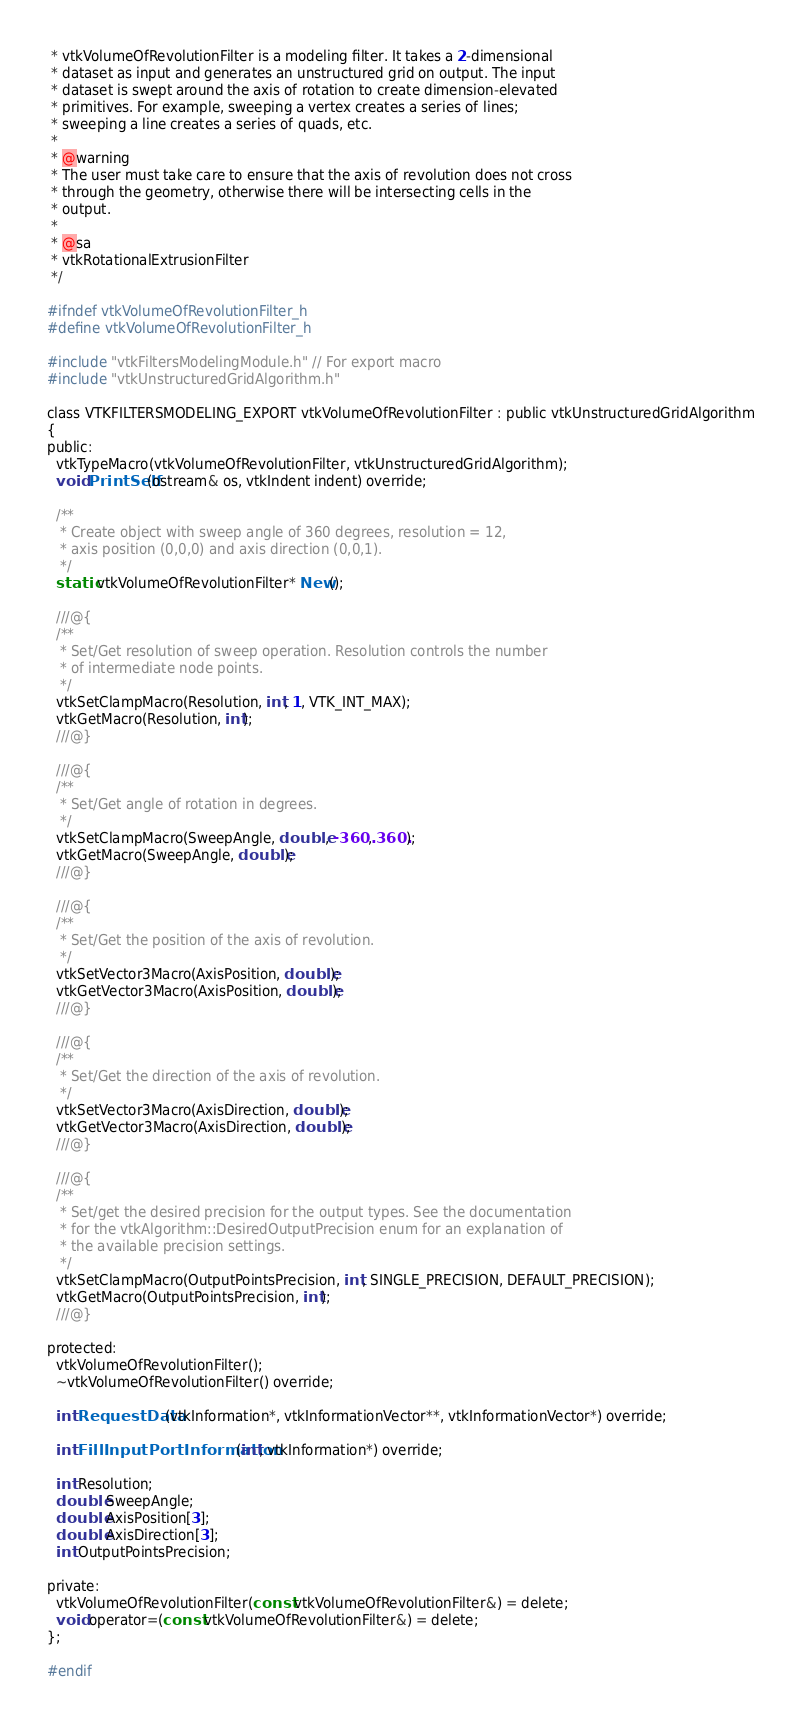<code> <loc_0><loc_0><loc_500><loc_500><_C_> * vtkVolumeOfRevolutionFilter is a modeling filter. It takes a 2-dimensional
 * dataset as input and generates an unstructured grid on output. The input
 * dataset is swept around the axis of rotation to create dimension-elevated
 * primitives. For example, sweeping a vertex creates a series of lines;
 * sweeping a line creates a series of quads, etc.
 *
 * @warning
 * The user must take care to ensure that the axis of revolution does not cross
 * through the geometry, otherwise there will be intersecting cells in the
 * output.
 *
 * @sa
 * vtkRotationalExtrusionFilter
 */

#ifndef vtkVolumeOfRevolutionFilter_h
#define vtkVolumeOfRevolutionFilter_h

#include "vtkFiltersModelingModule.h" // For export macro
#include "vtkUnstructuredGridAlgorithm.h"

class VTKFILTERSMODELING_EXPORT vtkVolumeOfRevolutionFilter : public vtkUnstructuredGridAlgorithm
{
public:
  vtkTypeMacro(vtkVolumeOfRevolutionFilter, vtkUnstructuredGridAlgorithm);
  void PrintSelf(ostream& os, vtkIndent indent) override;

  /**
   * Create object with sweep angle of 360 degrees, resolution = 12,
   * axis position (0,0,0) and axis direction (0,0,1).
   */
  static vtkVolumeOfRevolutionFilter* New();

  ///@{
  /**
   * Set/Get resolution of sweep operation. Resolution controls the number
   * of intermediate node points.
   */
  vtkSetClampMacro(Resolution, int, 1, VTK_INT_MAX);
  vtkGetMacro(Resolution, int);
  ///@}

  ///@{
  /**
   * Set/Get angle of rotation in degrees.
   */
  vtkSetClampMacro(SweepAngle, double, -360., 360.);
  vtkGetMacro(SweepAngle, double);
  ///@}

  ///@{
  /**
   * Set/Get the position of the axis of revolution.
   */
  vtkSetVector3Macro(AxisPosition, double);
  vtkGetVector3Macro(AxisPosition, double);
  ///@}

  ///@{
  /**
   * Set/Get the direction of the axis of revolution.
   */
  vtkSetVector3Macro(AxisDirection, double);
  vtkGetVector3Macro(AxisDirection, double);
  ///@}

  ///@{
  /**
   * Set/get the desired precision for the output types. See the documentation
   * for the vtkAlgorithm::DesiredOutputPrecision enum for an explanation of
   * the available precision settings.
   */
  vtkSetClampMacro(OutputPointsPrecision, int, SINGLE_PRECISION, DEFAULT_PRECISION);
  vtkGetMacro(OutputPointsPrecision, int);
  ///@}

protected:
  vtkVolumeOfRevolutionFilter();
  ~vtkVolumeOfRevolutionFilter() override;

  int RequestData(vtkInformation*, vtkInformationVector**, vtkInformationVector*) override;

  int FillInputPortInformation(int, vtkInformation*) override;

  int Resolution;
  double SweepAngle;
  double AxisPosition[3];
  double AxisDirection[3];
  int OutputPointsPrecision;

private:
  vtkVolumeOfRevolutionFilter(const vtkVolumeOfRevolutionFilter&) = delete;
  void operator=(const vtkVolumeOfRevolutionFilter&) = delete;
};

#endif
</code> 